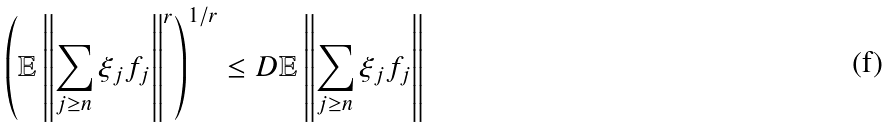<formula> <loc_0><loc_0><loc_500><loc_500>\left ( \mathbb { E } \left \| \sum _ { j \geq n } \xi _ { j } f _ { j } \right \| ^ { r } \right ) ^ { 1 / r } \leq D \mathbb { E } \left \| \sum _ { j \geq n } \xi _ { j } f _ { j } \right \|</formula> 